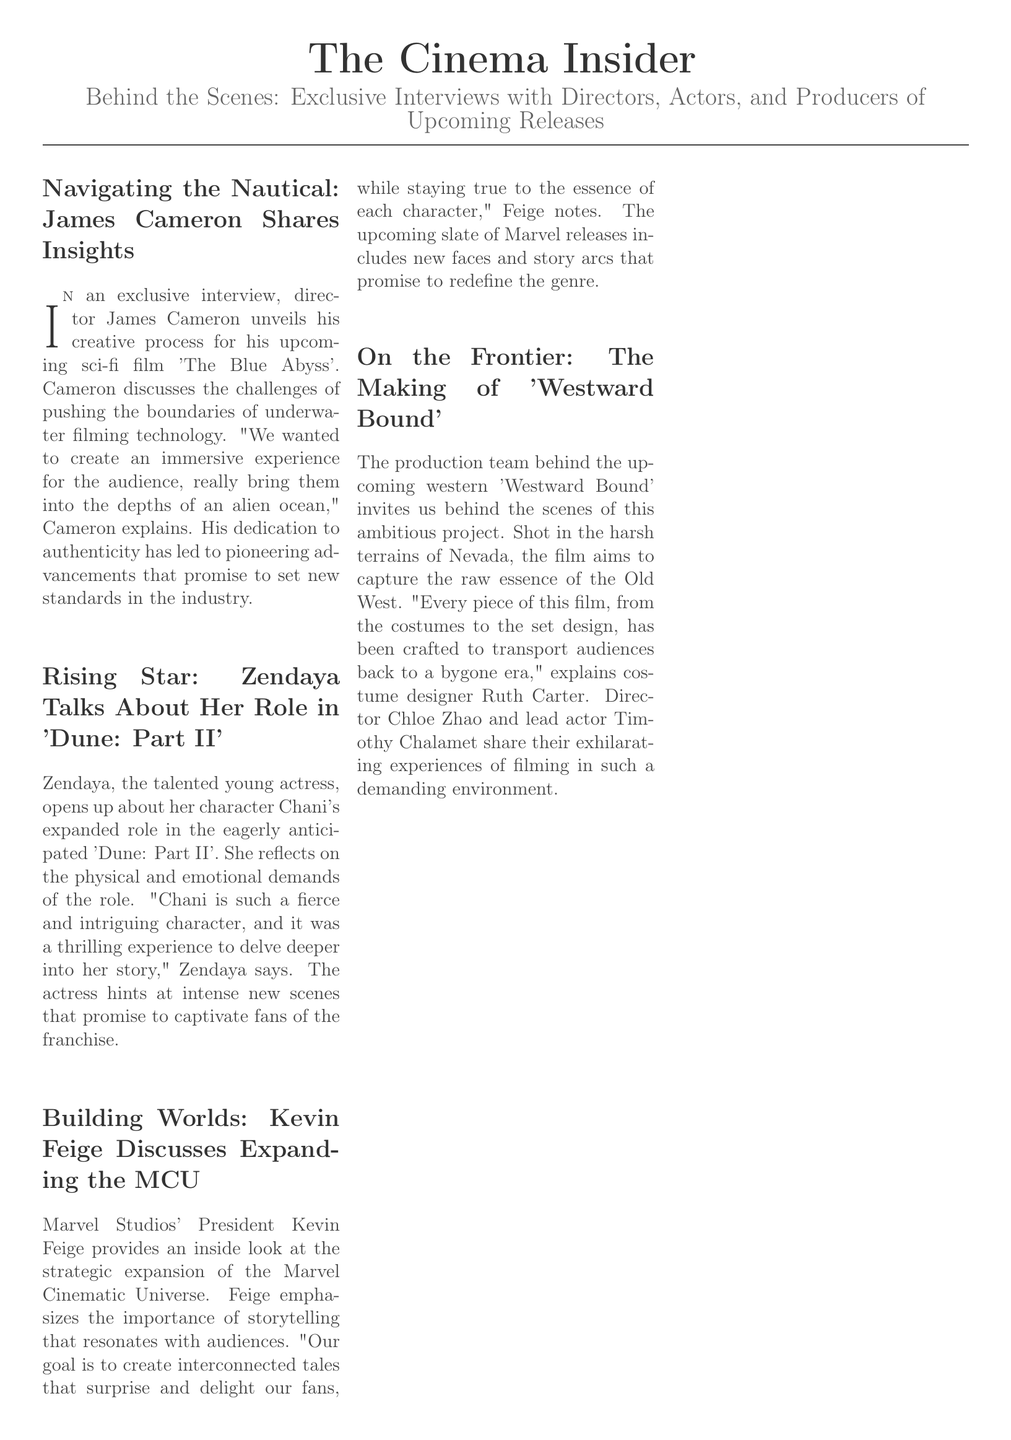what is the title of James Cameron's upcoming film? The title of James Cameron's upcoming film is mentioned in the document as 'The Blue Abyss'.
Answer: The Blue Abyss who plays Chani in 'Dune: Part II'? The document states that Zendaya plays the character Chani in 'Dune: Part II'.
Answer: Zendaya what role does Kevin Feige hold at Marvel Studios? Kevin Feige is identified as the President of Marvel Studios in the article.
Answer: President where was 'Westward Bound' filmed? The location for filming 'Westward Bound' is described as the harsh terrains of Nevada.
Answer: Nevada which designer is mentioned in relation to costume design for 'Westward Bound'? The document discusses costume designer Ruth Carter's involvement in the film 'Westward Bound'.
Answer: Ruth Carter what is the main theme discussed in Kevin Feige's interview? The main theme discussed by Kevin Feige revolves around the expansion of the Marvel Cinematic Universe and storytelling.
Answer: Expansion of the Marvel Cinematic Universe what type of film is 'The Blue Abyss'? James Cameron's upcoming film 'The Blue Abyss' is categorized as a sci-fi film in the document.
Answer: sci-fi who directed 'Westward Bound'? The document states that Chloe Zhao is the director of 'Westward Bound'.
Answer: Chloe Zhao what does Zendaya find thrilling about her experience in 'Dune: Part II'? Zendaya finds it thrilling to delve deeper into her character Chani's story in 'Dune: Part II'.
Answer: Delve deeper into her story what kind of experience does James Cameron aim to create for the audience? James Cameron aims to create an immersive experience by bringing audiences into the depths of an alien ocean.
Answer: Immersive experience 